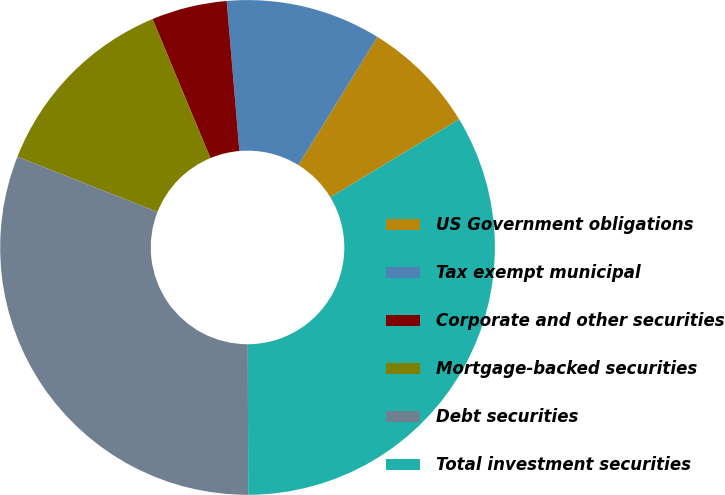<chart> <loc_0><loc_0><loc_500><loc_500><pie_chart><fcel>US Government obligations<fcel>Tax exempt municipal<fcel>Corporate and other securities<fcel>Mortgage-backed securities<fcel>Debt securities<fcel>Total investment securities<nl><fcel>7.54%<fcel>10.14%<fcel>4.93%<fcel>12.75%<fcel>31.02%<fcel>33.62%<nl></chart> 